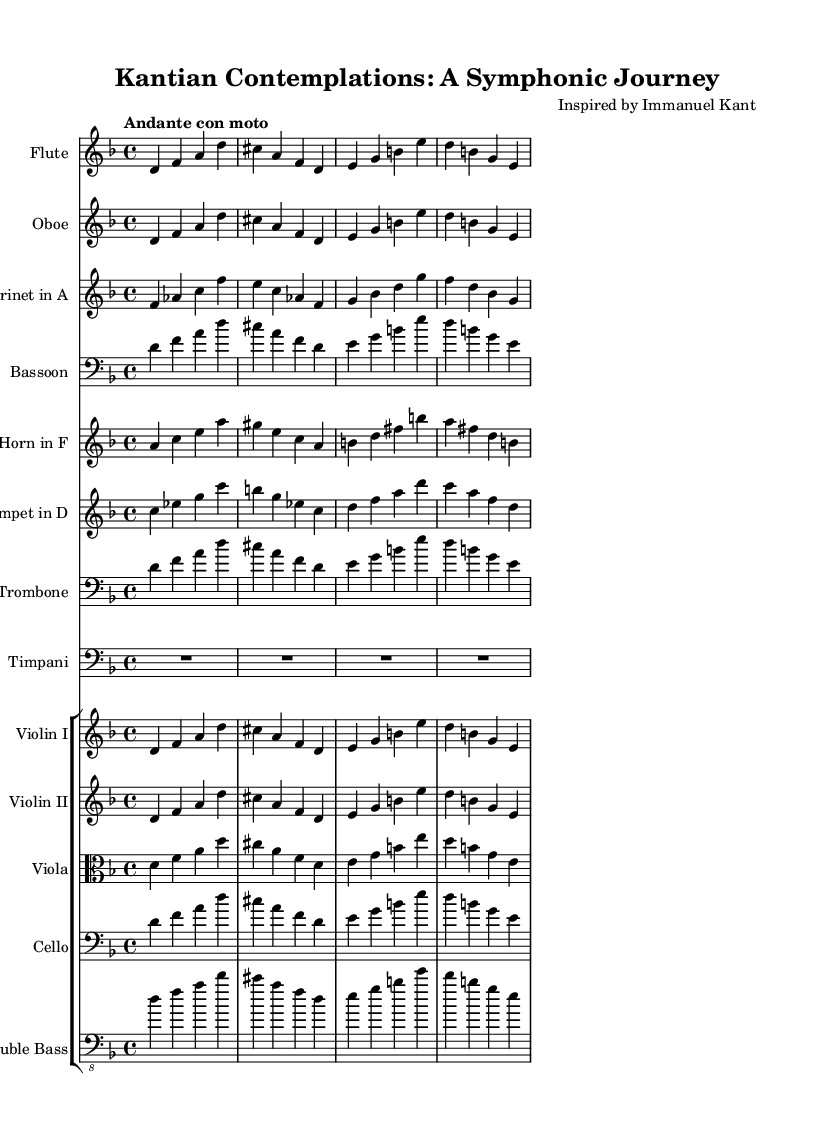What is the key signature of this music? The key signature is D minor, which has one flat, specifically B flat. This is determined by observing the two clefs in the staff, looking at the key signature placement at the beginning before the first measure.
Answer: D minor What is the time signature of this music? The time signature is 4/4, which indicates that there are four beats in each measure and that a quarter note receives one beat. This is evident from the notation appearing directly after the key signature in the first staff.
Answer: 4/4 What is the tempo marking of this music? The tempo marking is "Andante con moto," indicating a moderate pace with some movement. The marking is found at the beginning of the sheet music, indicating the intended speed of the piece.
Answer: Andante con moto How many instruments are used in this symphony? There are ten unique instruments featured in the score, which are Flute, Oboe, Clarinet in A, Bassoon, Horn in F, Trumpet in D, Trombone, Timpani, Violin I, Violin II, Viola, Cello, and Double Bass. By counting each staff corresponding to an instrument, we find this total.
Answer: Ten Which instruments are playing the main theme in unison? The instruments playing the main theme in unison are Flute, Oboe, Violin I, and Violin II. Observing the staves reveals these instruments sharing the same melody line without alterations for several measures.
Answer: Flute, Oboe, Violin I, Violin II What is the clef used by the Viola staff? The clef used by the Viola staff is the alto clef, which indicates the pitch range suited for the viola. This is shown at the beginning of the Viola staff, denoting the notes it will read.
Answer: Alto clef What is the harmonic structure of the first theme presented? The harmonic structure of the first theme is built primarily around the tonic (D minor) and features its relative major (F major) with passing tones such as E and G. Analyzing the notes in the first theme allows us to identify the roots of the chords that stem from these notes.
Answer: D minor and F major 